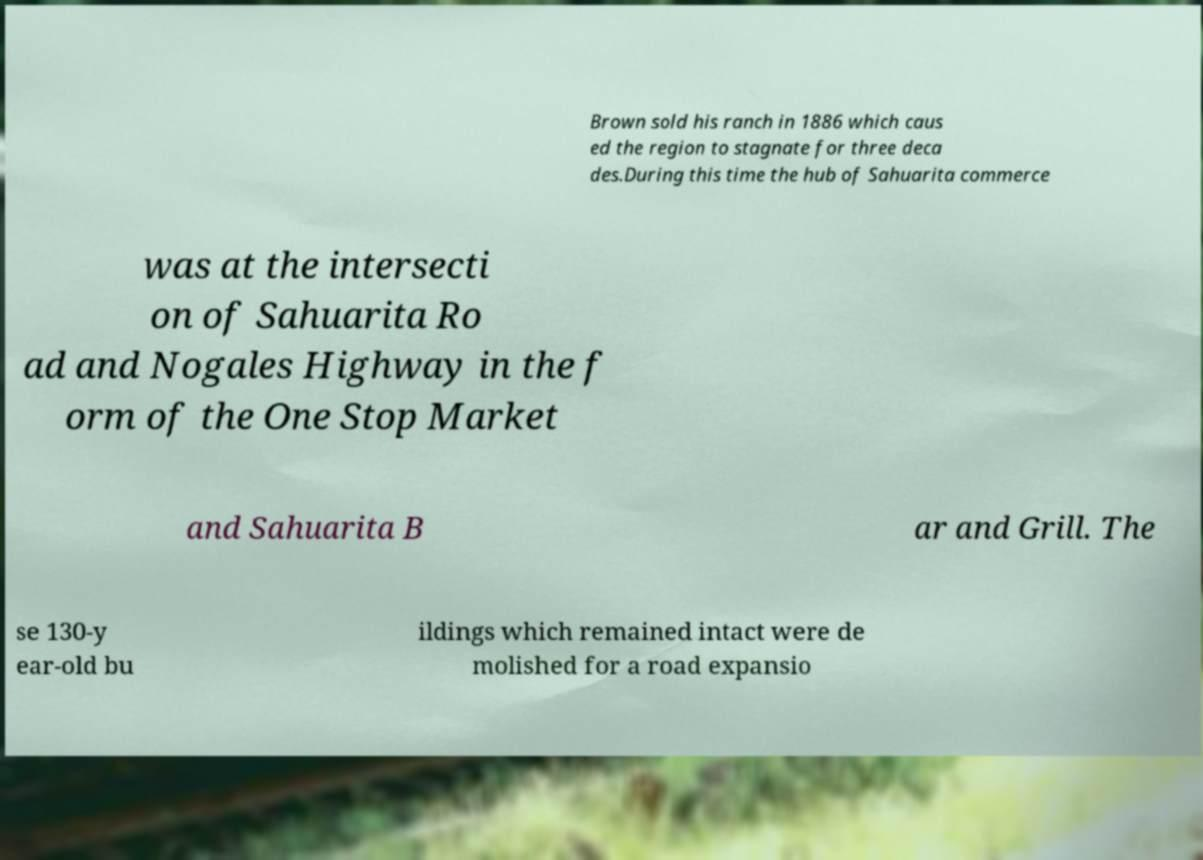What messages or text are displayed in this image? I need them in a readable, typed format. Brown sold his ranch in 1886 which caus ed the region to stagnate for three deca des.During this time the hub of Sahuarita commerce was at the intersecti on of Sahuarita Ro ad and Nogales Highway in the f orm of the One Stop Market and Sahuarita B ar and Grill. The se 130-y ear-old bu ildings which remained intact were de molished for a road expansio 